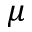<formula> <loc_0><loc_0><loc_500><loc_500>\mu</formula> 